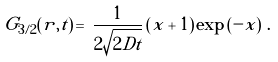Convert formula to latex. <formula><loc_0><loc_0><loc_500><loc_500>G _ { 3 / 2 } ( r , t ) \, = \, \frac { 1 } { 2 \sqrt { 2 D t } } \left ( x + 1 \right ) \exp \left ( - x \right ) \, .</formula> 